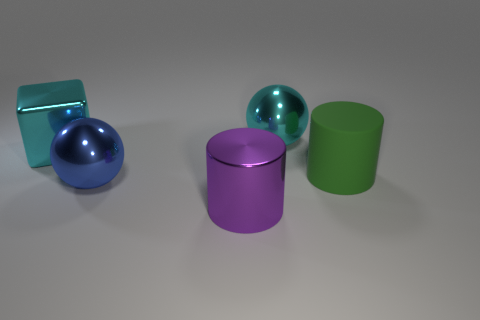The metal object that is the same color as the cube is what shape?
Offer a very short reply. Sphere. Is there anything else that is the same color as the large block?
Give a very brief answer. Yes. What is the large cyan block made of?
Make the answer very short. Metal. How many other things are made of the same material as the cyan cube?
Your response must be concise. 3. What number of metal spheres are there?
Keep it short and to the point. 2. What is the material of the other thing that is the same shape as the big green rubber object?
Your answer should be compact. Metal. Do the large cylinder to the left of the cyan ball and the green object have the same material?
Offer a terse response. No. Is the number of big cubes on the right side of the large green cylinder greater than the number of cylinders in front of the large blue sphere?
Make the answer very short. No. What size is the purple object?
Provide a short and direct response. Large. There is a blue object that is the same material as the purple object; what shape is it?
Ensure brevity in your answer.  Sphere. 